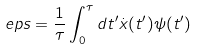Convert formula to latex. <formula><loc_0><loc_0><loc_500><loc_500>\ e p s = \frac { 1 } { \tau } \int _ { 0 } ^ { \tau } d t ^ { \prime } \dot { x } ( t ^ { \prime } ) \psi ( t ^ { \prime } )</formula> 